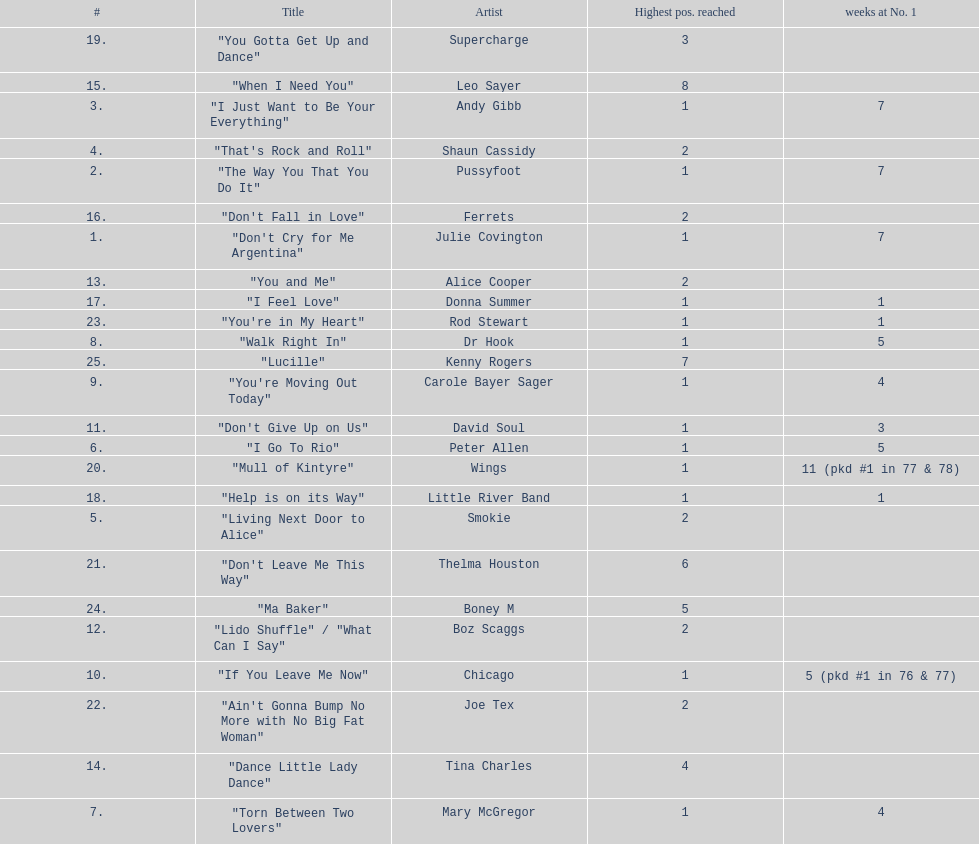How many weeks did julie covington's "don't cry for me argentina" spend at the top of australia's singles chart? 7. 